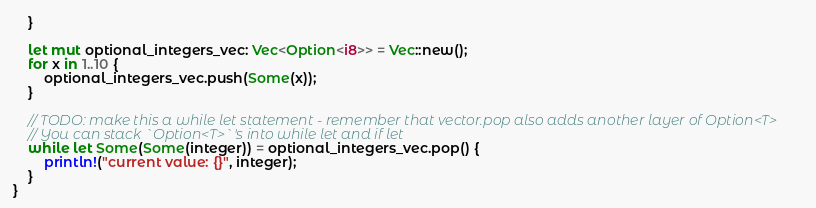<code> <loc_0><loc_0><loc_500><loc_500><_Rust_>    }

    let mut optional_integers_vec: Vec<Option<i8>> = Vec::new();
    for x in 1..10 {
        optional_integers_vec.push(Some(x));
    }

    // TODO: make this a while let statement - remember that vector.pop also adds another layer of Option<T>
    // You can stack `Option<T>`'s into while let and if let
    while let Some(Some(integer)) = optional_integers_vec.pop() {
        println!("current value: {}", integer);
    }
}
</code> 